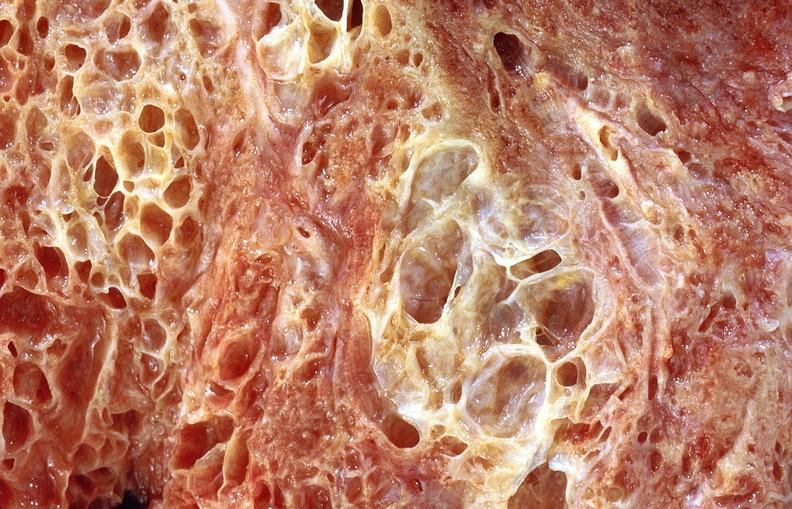what is present?
Answer the question using a single word or phrase. Respiratory 